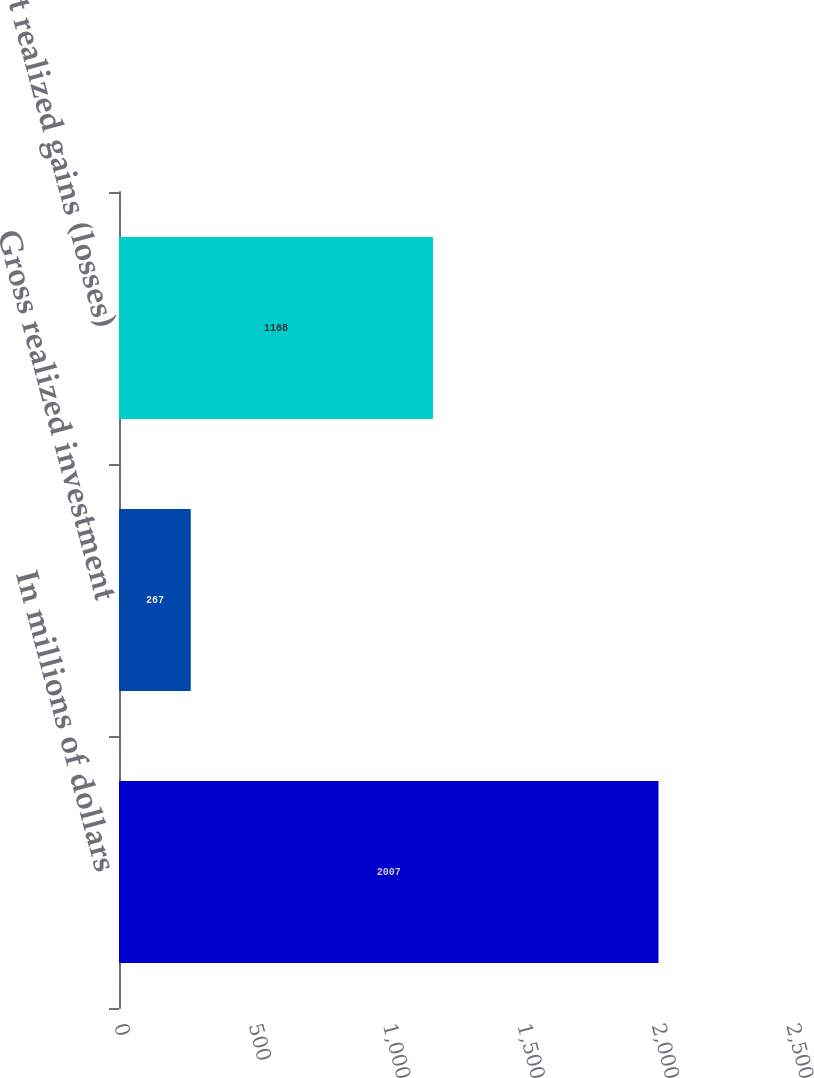Convert chart to OTSL. <chart><loc_0><loc_0><loc_500><loc_500><bar_chart><fcel>In millions of dollars<fcel>Gross realized investment<fcel>Net realized gains (losses)<nl><fcel>2007<fcel>267<fcel>1168<nl></chart> 